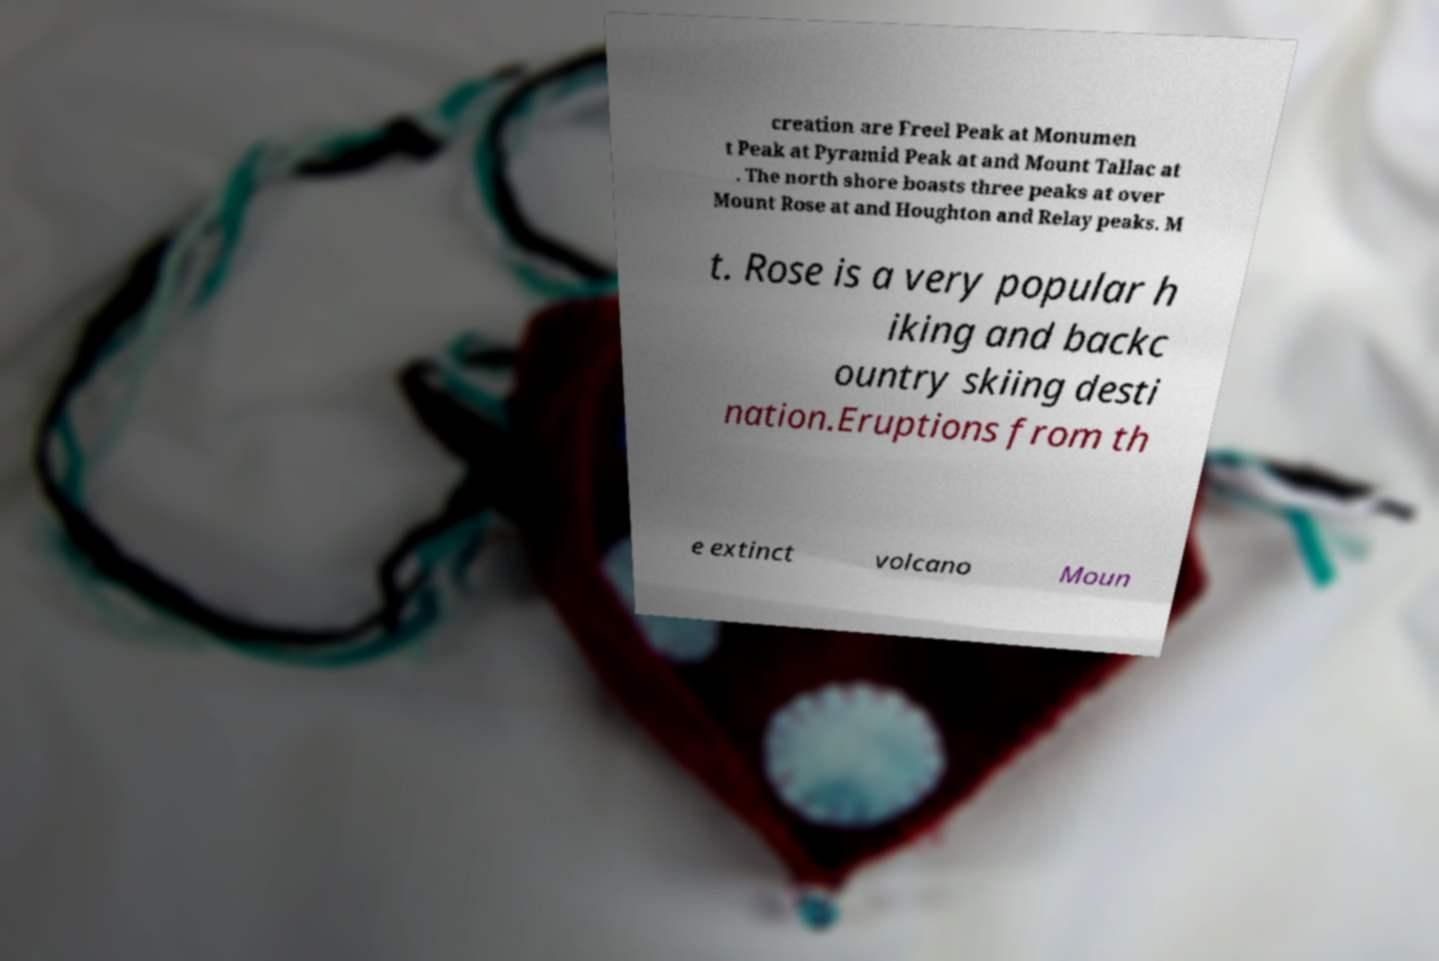Could you extract and type out the text from this image? creation are Freel Peak at Monumen t Peak at Pyramid Peak at and Mount Tallac at . The north shore boasts three peaks at over Mount Rose at and Houghton and Relay peaks. M t. Rose is a very popular h iking and backc ountry skiing desti nation.Eruptions from th e extinct volcano Moun 